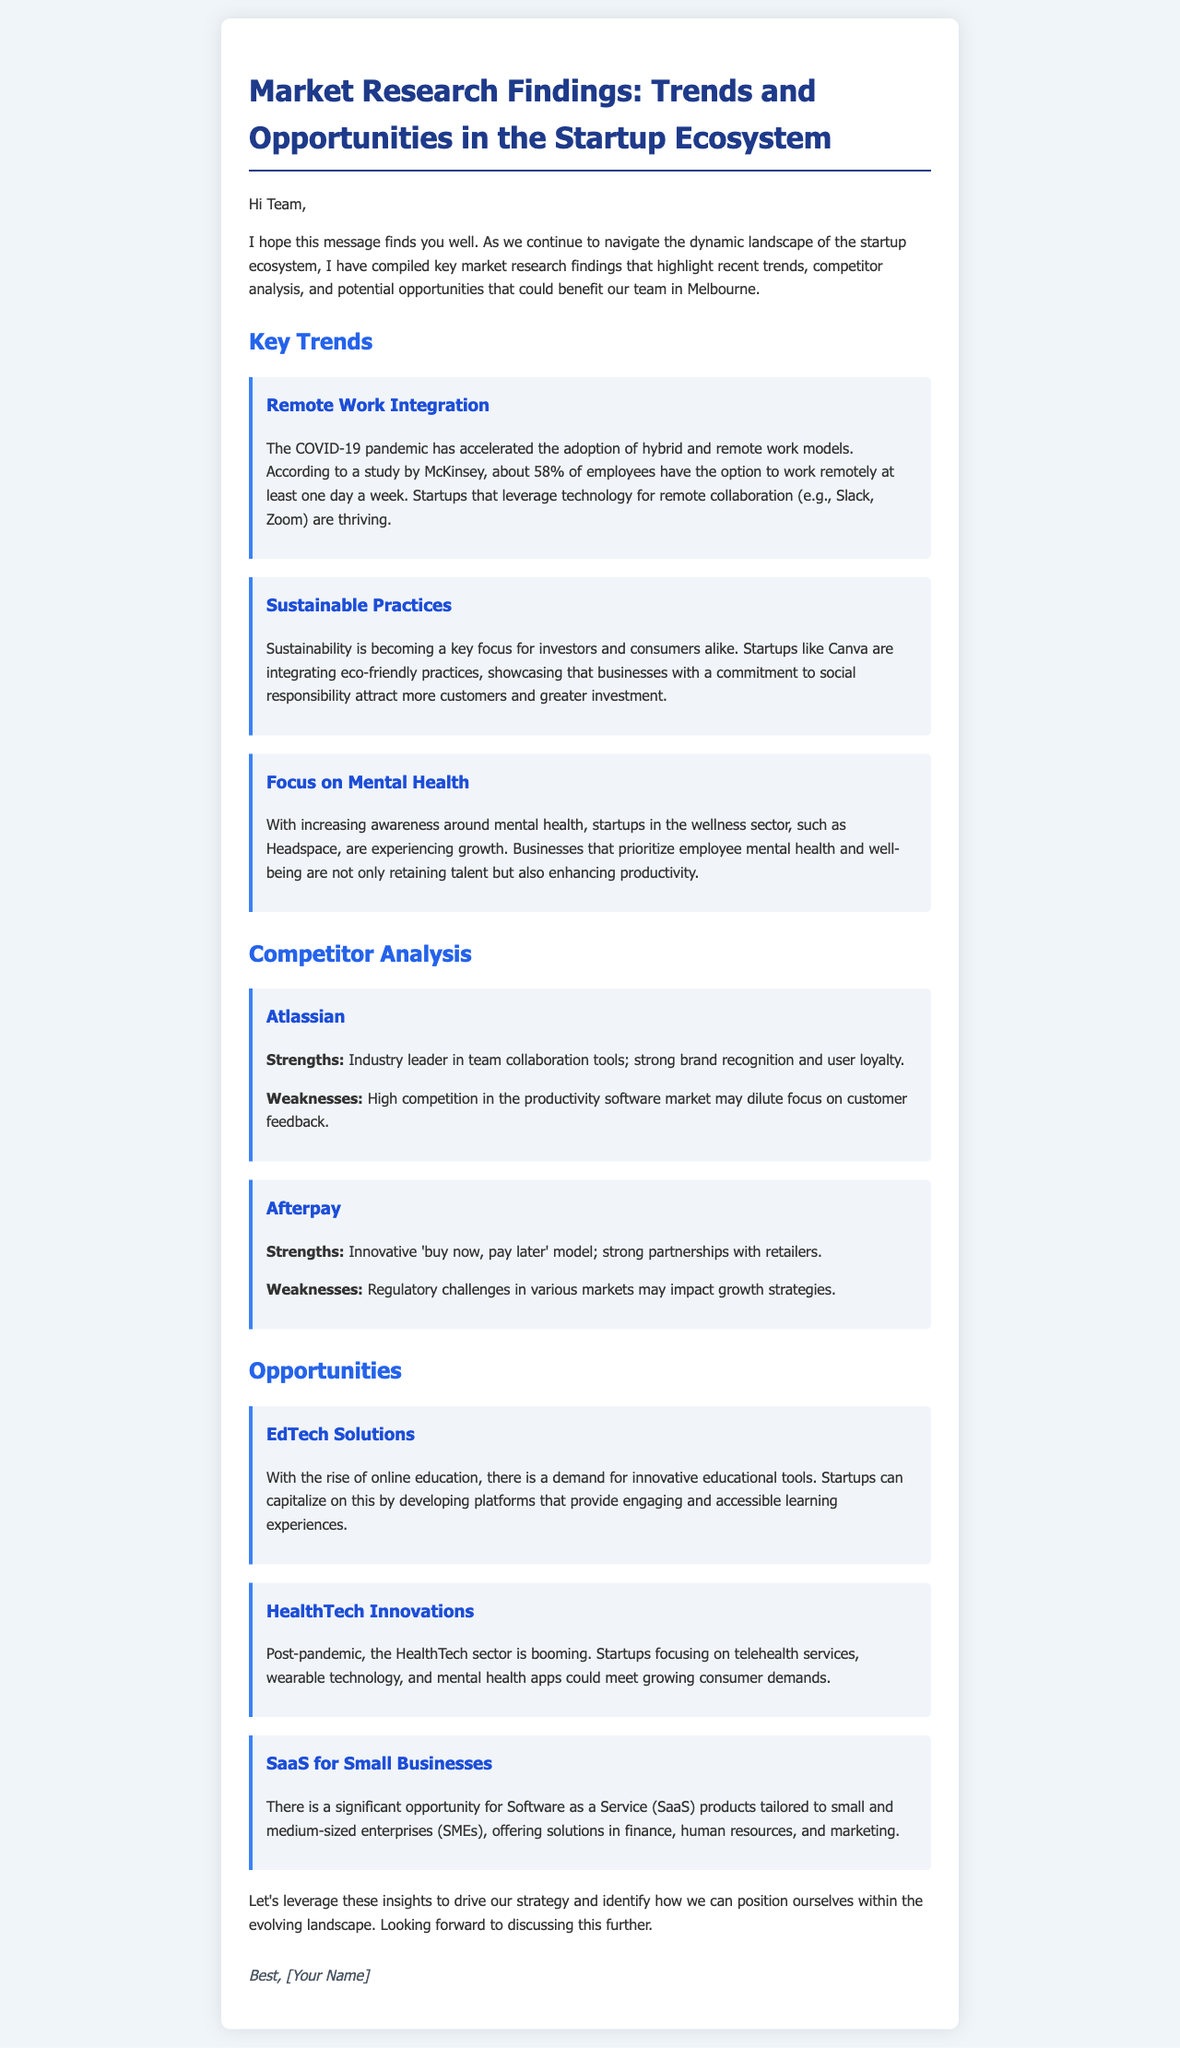What percentage of employees have the option to work remotely? The document states that about 58% of employees have the option to work remotely at least one day a week.
Answer: 58% Which startup is mentioned as integrating eco-friendly practices? The document references Canva as a startup integrating eco-friendly practices.
Answer: Canva What key focus is becoming significant for investors and consumers? According to the trends mentioned, sustainability is becoming a key focus for investors and consumers.
Answer: Sustainability What is a strength of Atlassian? The document outlines that Atlassian is an industry leader in team collaboration tools as a strength.
Answer: Industry leader in team collaboration tools Which sector is booming post-pandemic? The document indicates that the HealthTech sector is booming post-pandemic.
Answer: HealthTech What innovative model does Afterpay use? Afterpay is noted for its innovative 'buy now, pay later' model.
Answer: buy now, pay later What type of solutions present an opportunity in the startup ecosystem? The document mentions EdTech solutions as an opportunity in the startup ecosystem.
Answer: EdTech solutions Which companies focus on mental health according to the trends? The document mentions Headspace as a startup focused on mental health.
Answer: Headspace How many opportunities are listed in the document? The document lists three opportunities within the startup ecosystem.
Answer: Three 